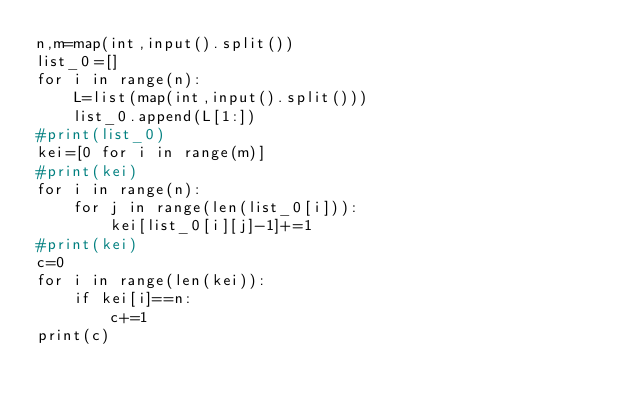<code> <loc_0><loc_0><loc_500><loc_500><_Python_>n,m=map(int,input().split())
list_0=[]
for i in range(n):
    L=list(map(int,input().split()))
    list_0.append(L[1:])
#print(list_0)
kei=[0 for i in range(m)]
#print(kei)
for i in range(n):
    for j in range(len(list_0[i])):
        kei[list_0[i][j]-1]+=1
#print(kei)
c=0
for i in range(len(kei)):
    if kei[i]==n:
        c+=1
print(c)</code> 